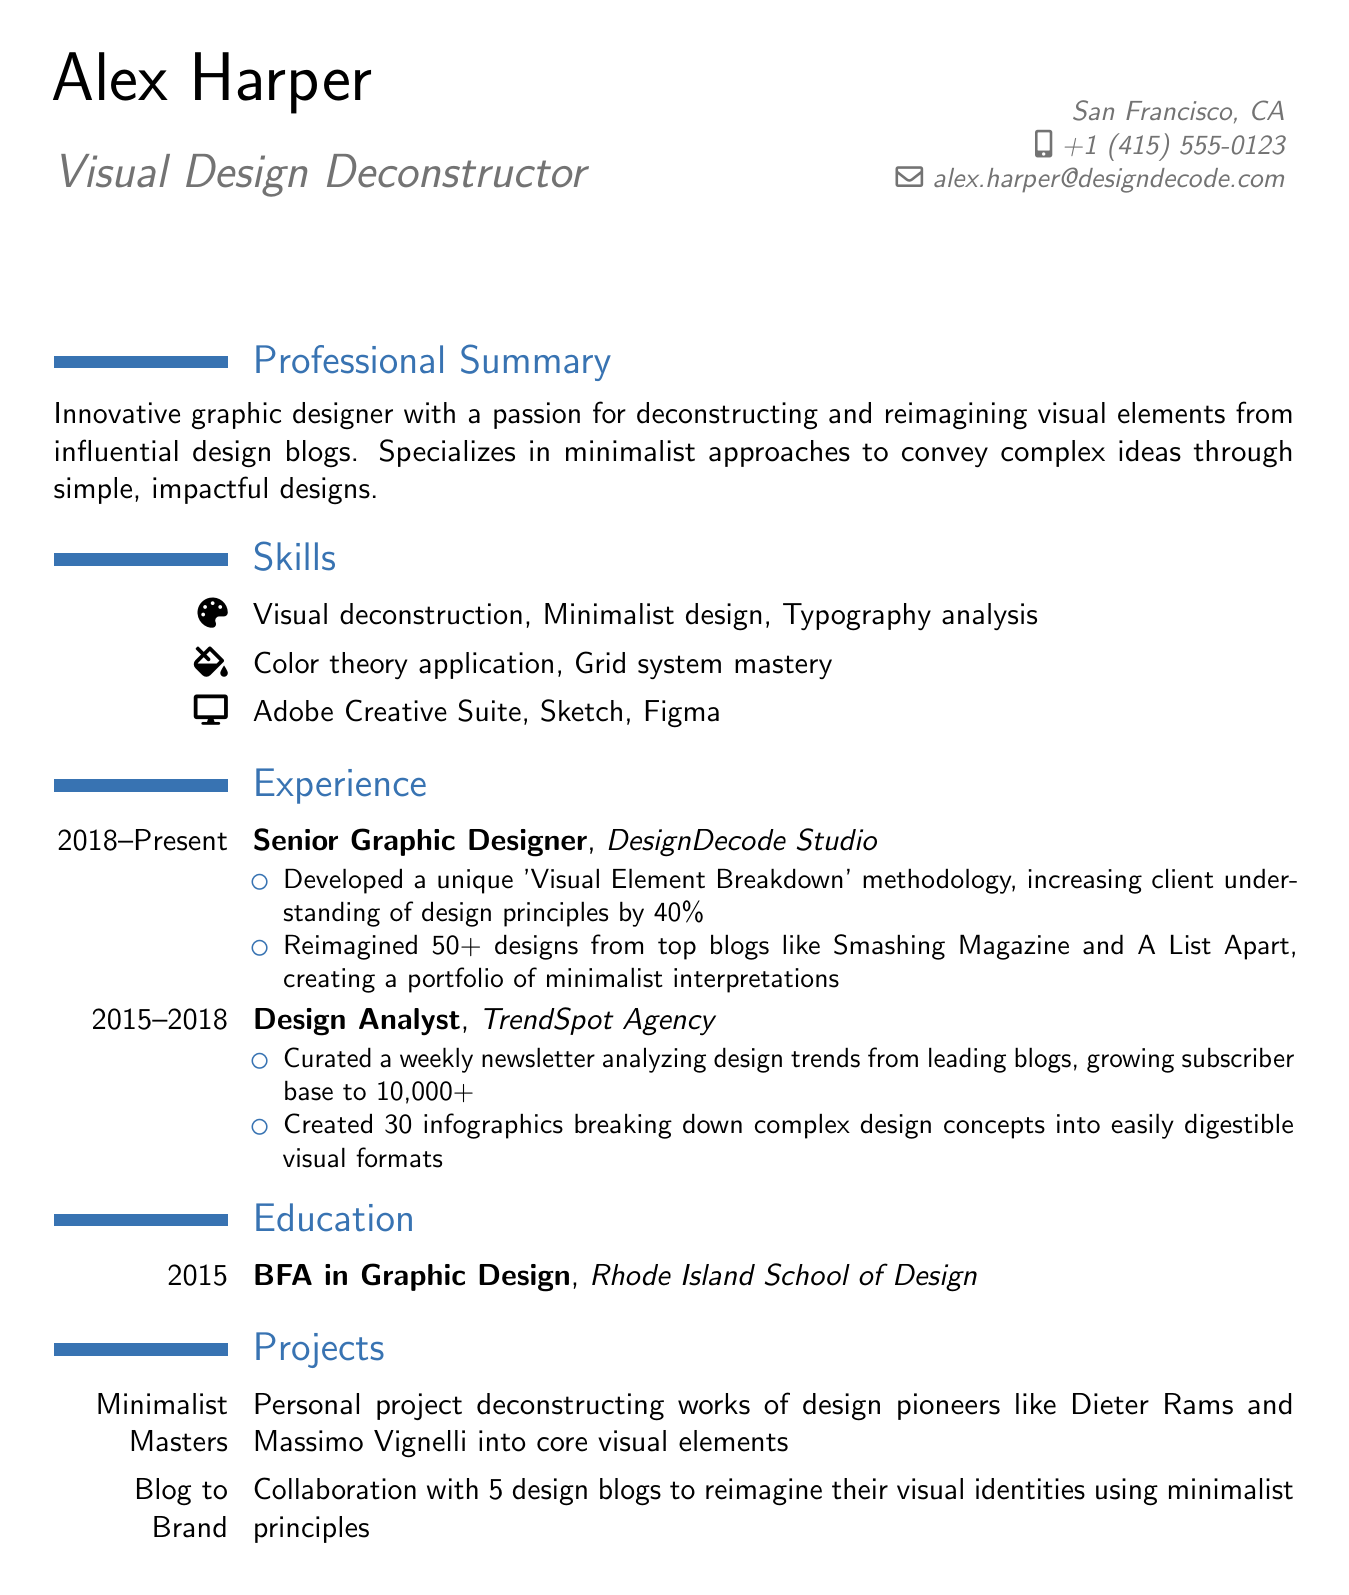What is the name of the designer? The designer's name is explicitly mentioned in the personal information section of the document.
Answer: Alex Harper What is the title of the document? The title can be inferred from the personal information section where it defines the professional identity of the individual.
Answer: Visual Design Deconstructor Which company does the designer currently work for? The current employer is highlighted under the experience section, indicating the designer's current professional affiliation.
Answer: DesignDecode Studio How long has the designer been at their current position? The duration at the current position is stated in the experience section, representing the timeline of their professional experience at that job.
Answer: 5 years What is one of the accomplishments listed under the Senior Graphic Designer role? Accomplishments are detailed as bullet points in the experience section, showcasing achievements in quantitative terms.
Answer: Developed a unique 'Visual Element Breakdown' methodology, increasing client understanding of design principles by 40% What degree did the designer earn? This information is found in the education section, indicating the designer's academic background.
Answer: BFA in Graphic Design What is the name of one project highlighted by the designer? Projects are explicitly listed in the projects section, naming personal or collaborative work undertaken by the designer.
Answer: Minimalist Masters How many infographics did the designer create? The specific achievement regarding infographics can be found in the experience section, showing the volume of work produced.
Answer: 30 infographics What software skills does the designer list? The skills section details the software proficiency, providing specific tools the designer is experienced with.
Answer: Adobe Creative Suite, Sketch, Figma 